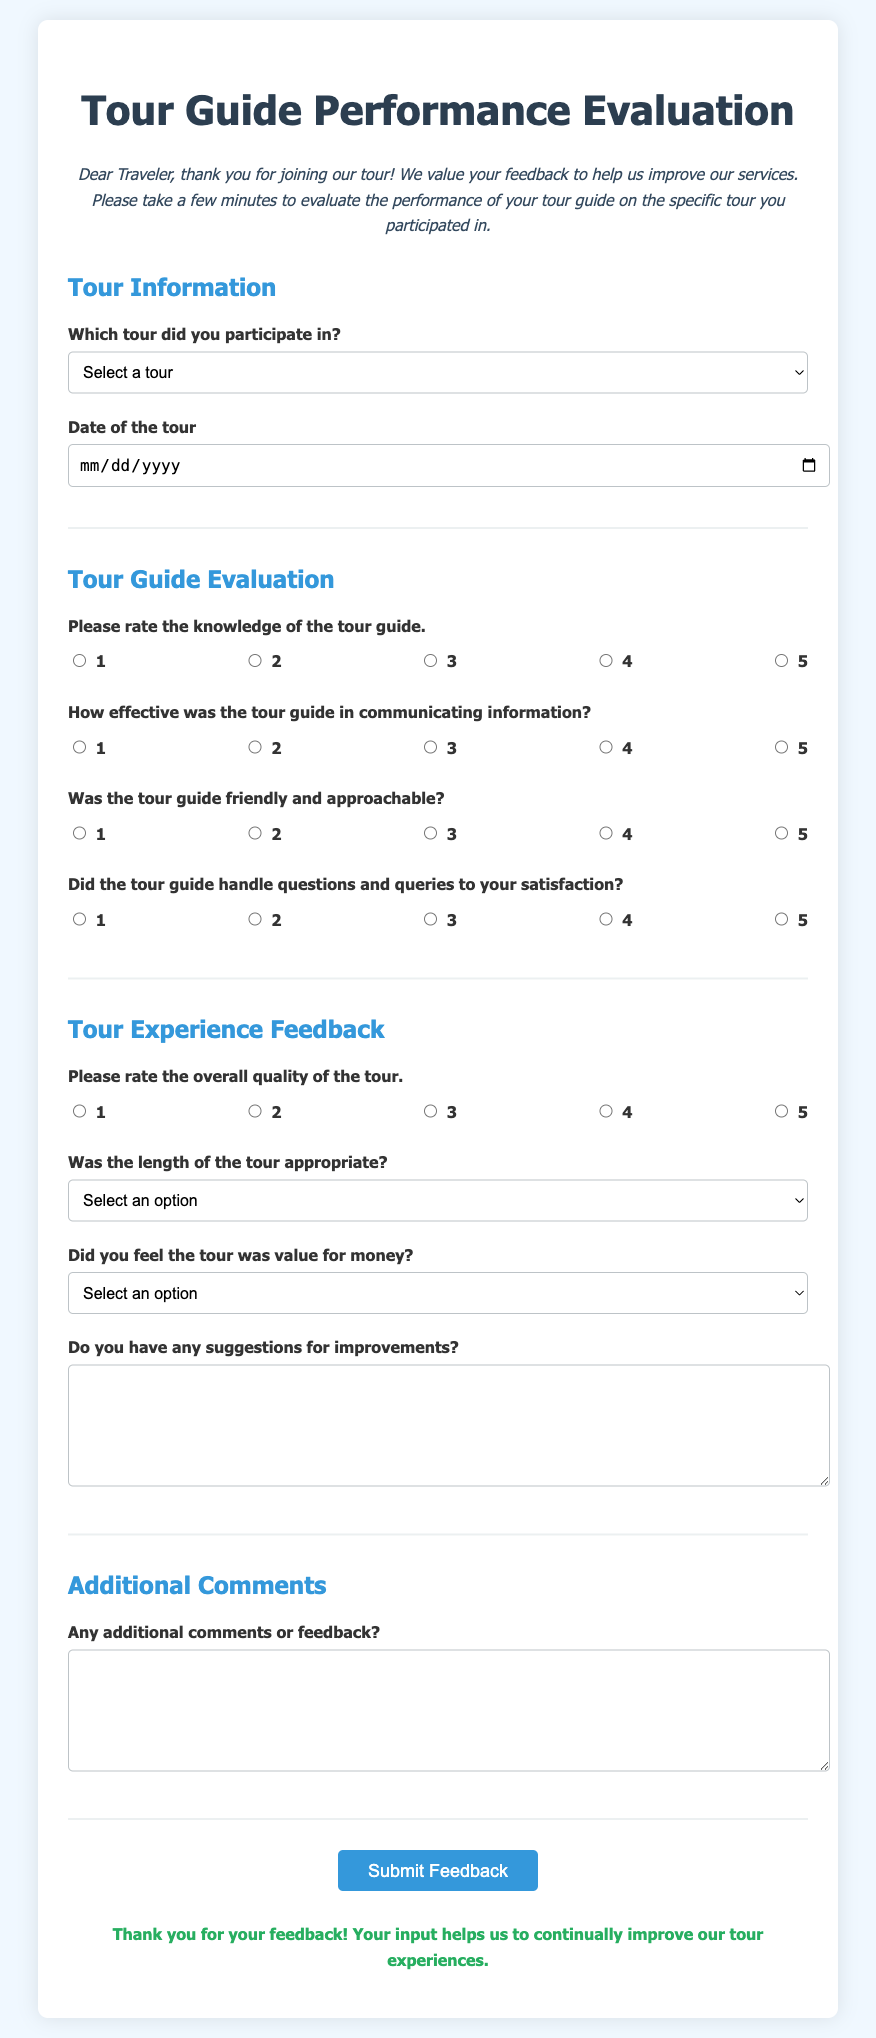Which tours are listed in the survey? The survey lists four specific tours that participants can select from the dropdown.
Answer: Historic City Walking Tour, Mountain Adventure Hike, Cultural Heritage Exploration, Gourmet Food Tasting Tour What is the required input for the tour date? The survey specifies that the user must provide the date of the tour.
Answer: Date of the tour How many questions are asked to evaluate the tour guide's performance? There are four distinct questions evaluating the tour guide's performance presented in the document.
Answer: Four What rating scale is used for evaluating the effectiveness of communication? The survey includes a five-point rating scale with options from one to five for evaluating communication effectiveness.
Answer: Five-point rating scale What is the purpose of the 'Do you have any suggestions for improvements?' question? This question aims to gather participant feedback specifically on how the tour experience could be enhanced.
Answer: Feedback on improvements What is the last section in the survey? The last area of the document is focused on gathering any additional comments or feedback from the traveler.
Answer: Additional Comments 